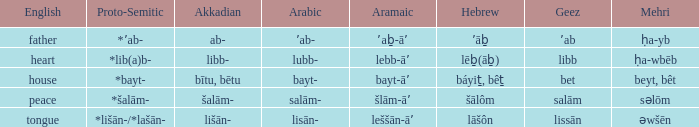If the geez is libb, what is the akkadian? Libb-. 